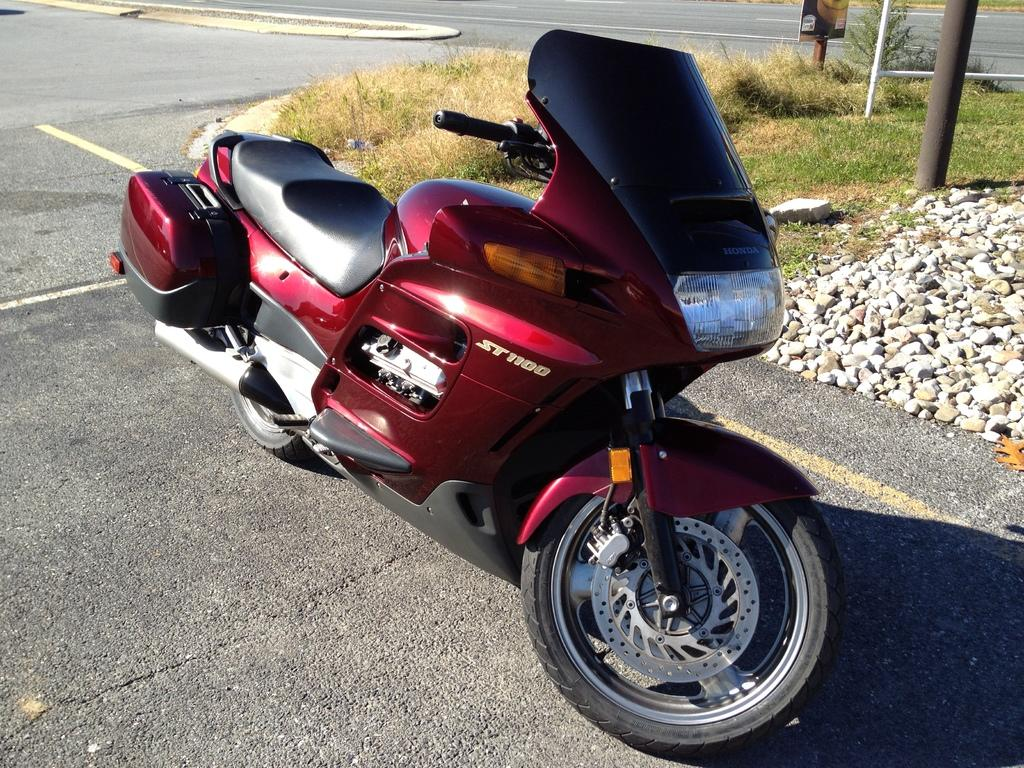What is the main subject in the center of the image? There is a bike in the center of the image. Where is the bike located? The bike is on the road. What can be seen to the right side of the image? There are stones visible to the right side of the image. What type of vegetation is present in the image? There is grass visible in the image. What structures can be seen in the image? There are poles in the image. What type of balloon is being used to protest against the nerve in the image? There is no balloon, protest, or nerve present in the image. 